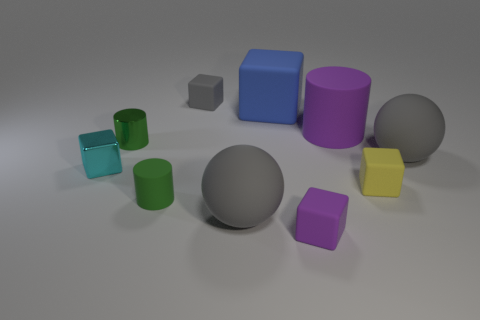Can you tell me which objects look similar in texture? Looking at the image, all the objects have a similar matte finish, suggesting that they might have a similar texture. They all reflect light in a soft way, implying a non-glossy surface that could be indicative of a similar material, possibly a type of plastic or 3D-printed filament. 